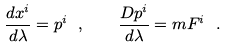<formula> <loc_0><loc_0><loc_500><loc_500>\frac { d x ^ { i } } { d \lambda } = p ^ { i } \ , \quad \frac { D p ^ { i } } { d \lambda } = m F ^ { i } \ .</formula> 